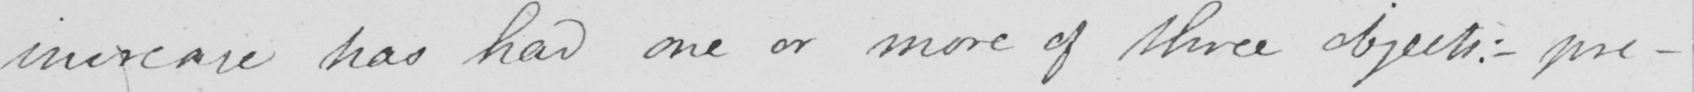What is written in this line of handwriting? increase has had one or more of three objects :  _  pre- 